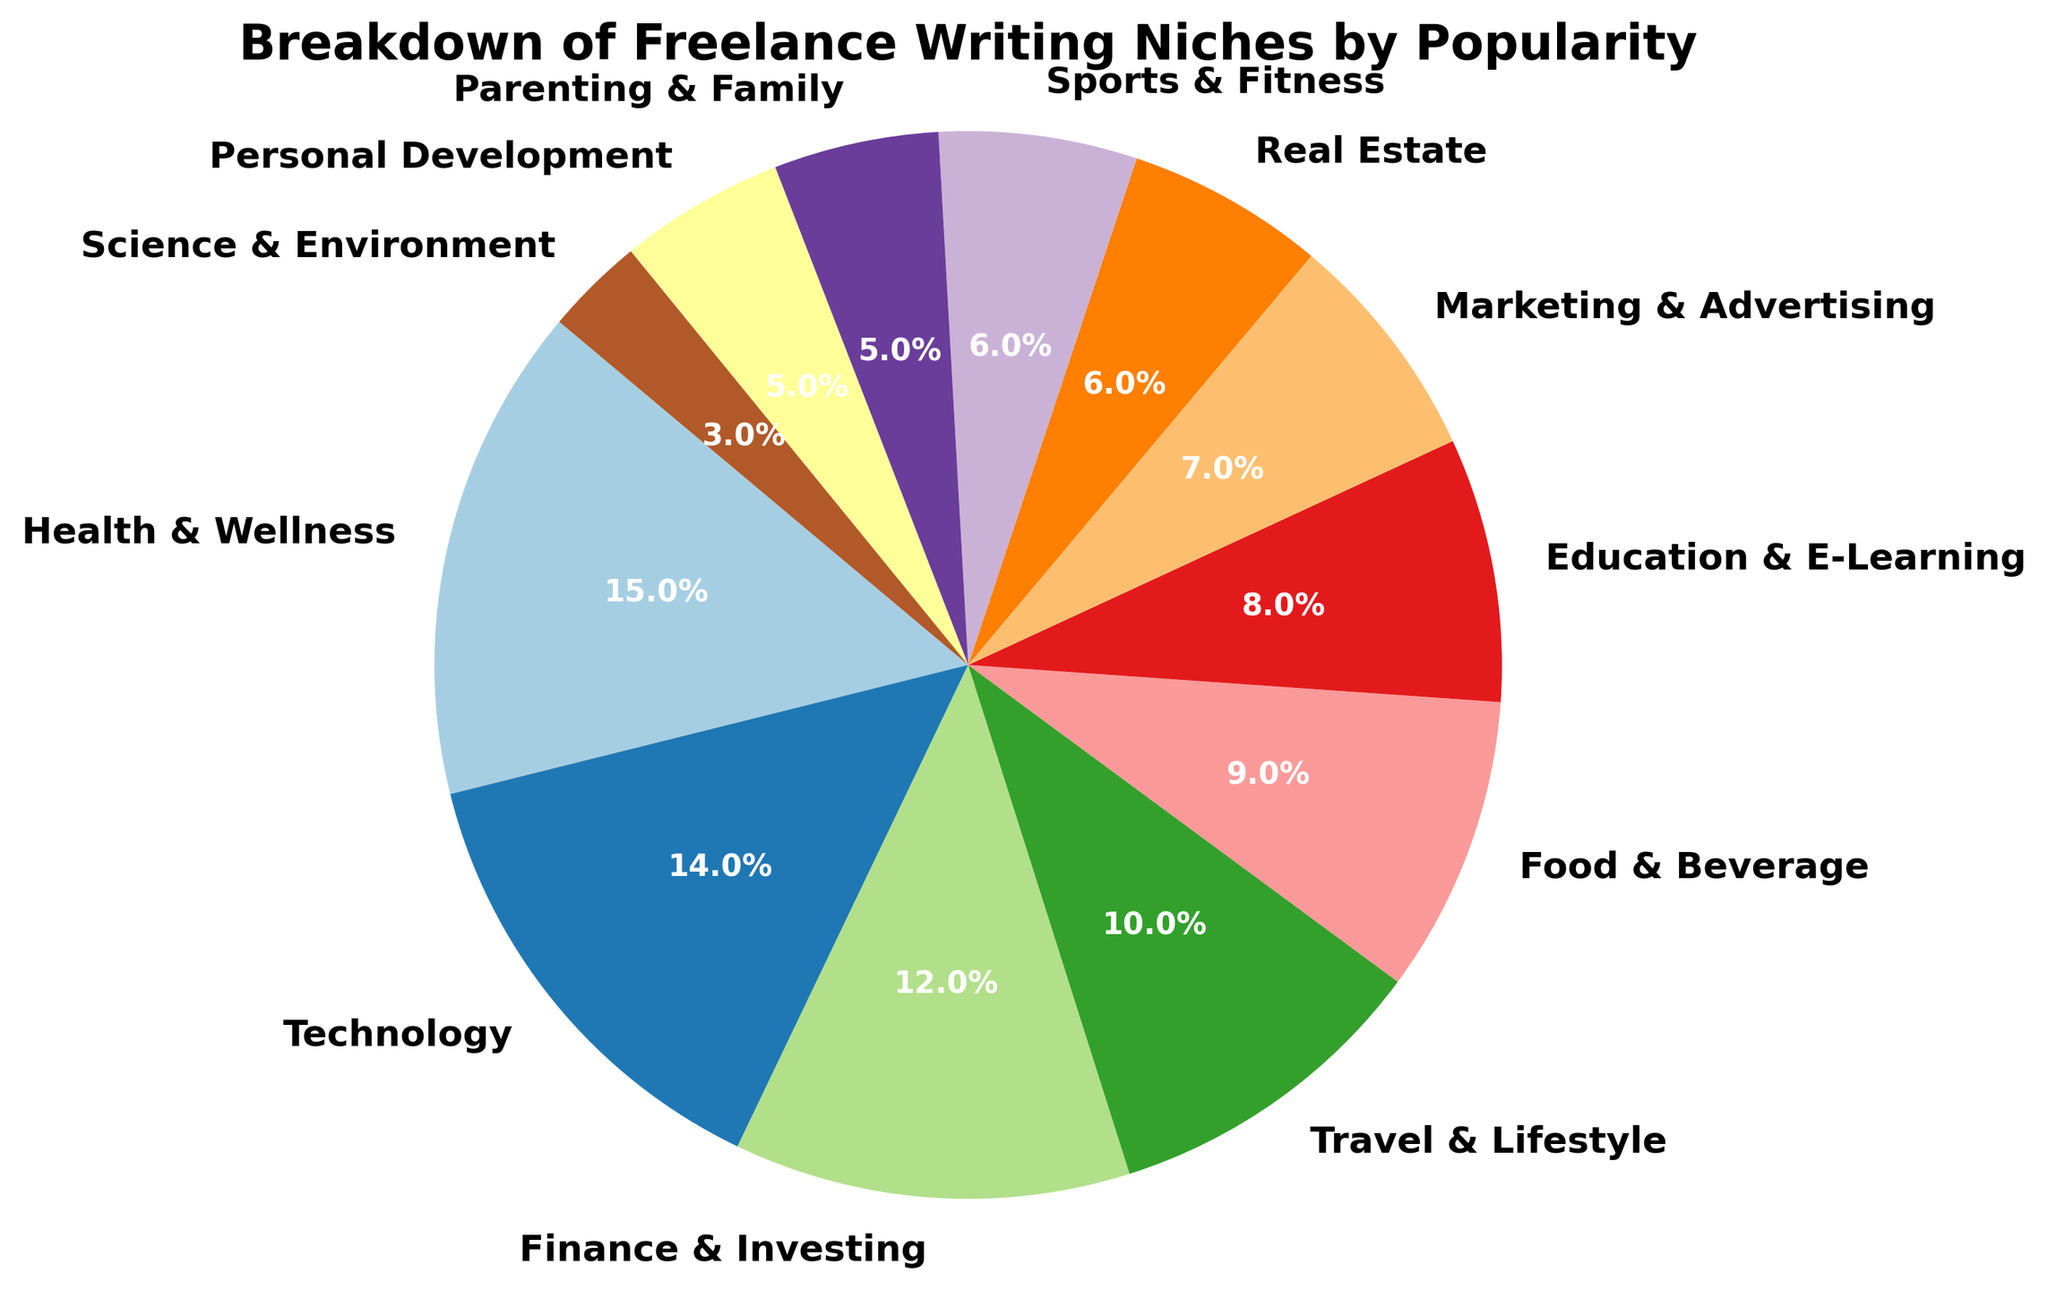What is the most popular freelance writing niche according to the pie chart? The largest slice of the pie represents the most popular category. According to the chart, the "Health & Wellness" category has the largest slice at 15%.
Answer: Health & Wellness What is the combined percentage of the "Finance & Investing" and "Real Estate" niches? Add the percentages of "Finance & Investing" (12%) and "Real Estate" (6%). 12% + 6% = 18%.
Answer: 18% Which two categories have the smallest slices, and what is their combined percentage? The smallest slices in the pie chart belong to "Personal Development" (5%) and "Science & Environment" (3%). Add these percentages: 5% + 3% = 8%.
Answer: Personal Development and Science & Environment, 8% Is the "Technology" niche more popular than "Education & E-Learning"? Compare the slices for "Technology" and "Education & E-Learning". "Technology" has a larger slice (14%) than "Education & E-Learning" (8%).
Answer: Yes What is the difference in percentage between "Health & Wellness" and "Parenting & Family"? Subtract the percentage of "Parenting & Family" (5%) from "Health & Wellness" (15%). 15% - 5% = 10%.
Answer: 10% How does the popularity of the "Travel & Lifestyle" niche compare to "Marketing & Advertising"? Compare the slices. "Travel & Lifestyle" has a larger percentage (10%) compared to "Marketing & Advertising" (7%).
Answer: Travel & Lifestyle is more popular What is the total percentage of the niches that have a popularity of 10% or more? Identify the niches with 10% or more: "Health & Wellness" (15%), "Technology" (14%), "Finance & Investing" (12%), and "Travel & Lifestyle" (10%). Add them: 15% + 14% + 12% + 10% = 51%.
Answer: 51% Which category is more popular: "Education & E-Learning" or "Food & Beverage"? Compare the slices. "Food & Beverage" has a larger percentage (9%) compared to "Education & E-Learning" (8%).
Answer: Food & Beverage What are the color categories used for "Finance & Investing" and "Sports & Fitness"? Visually identify the colors corresponding to the labels "Finance & Investing" (12%) and "Sports & Fitness" (6%). The exact colors may vary based on the specific palette used, but typically they will be distinguishable.
Answer: Colors will vary (usually identifiable by shades in the chart) By how much does the "Finance & Investing" percentage exceed "Science & Environment"? Subtract the percentage of "Science & Environment" (3%) from "Finance & Investing" (12%). 12% - 3% = 9%.
Answer: 9% 